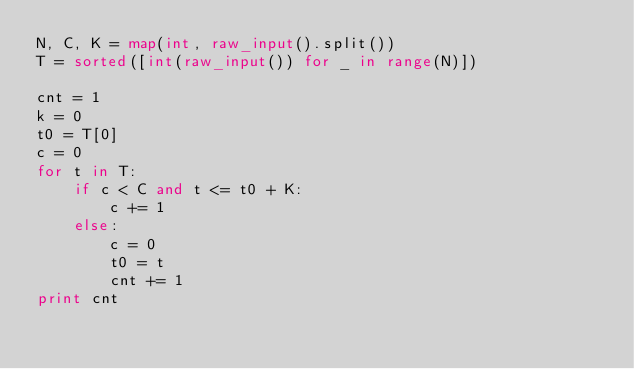Convert code to text. <code><loc_0><loc_0><loc_500><loc_500><_Python_>N, C, K = map(int, raw_input().split())
T = sorted([int(raw_input()) for _ in range(N)])

cnt = 1
k = 0
t0 = T[0]
c = 0
for t in T:
    if c < C and t <= t0 + K:
        c += 1
    else:
        c = 0
        t0 = t
        cnt += 1
print cnt
</code> 